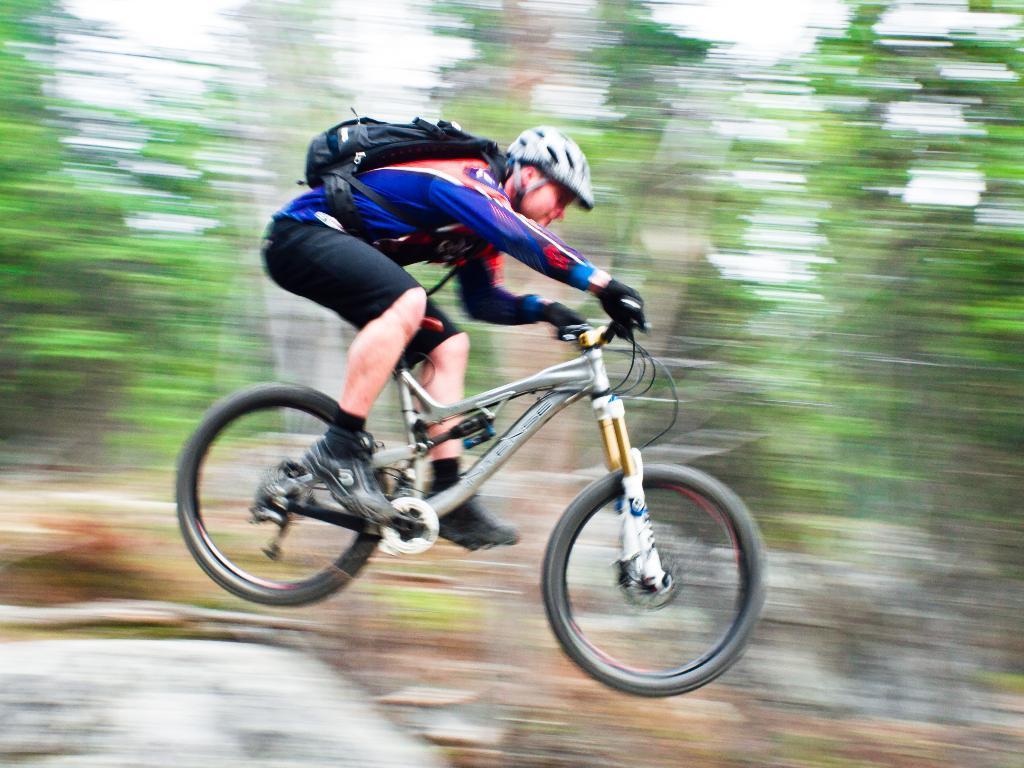In one or two sentences, can you explain what this image depicts? In the center of the image we can see a man sitting on the bicycle and jumping. In the background there are trees and sky. 